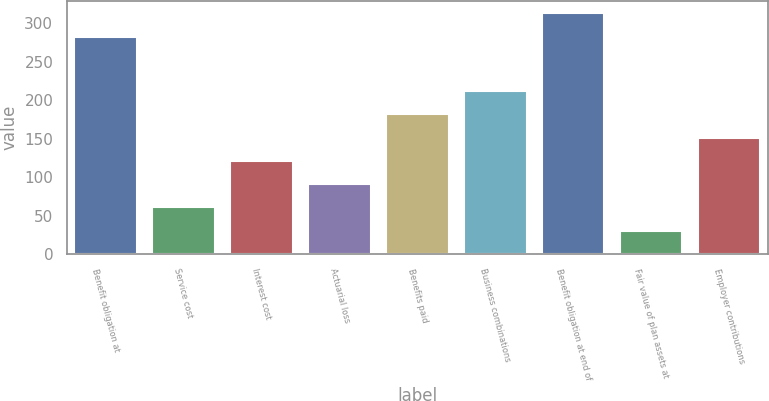Convert chart to OTSL. <chart><loc_0><loc_0><loc_500><loc_500><bar_chart><fcel>Benefit obligation at<fcel>Service cost<fcel>Interest cost<fcel>Actuarial loss<fcel>Benefits paid<fcel>Business combinations<fcel>Benefit obligation at end of<fcel>Fair value of plan assets at<fcel>Employer contributions<nl><fcel>282.7<fcel>60.64<fcel>121.18<fcel>90.91<fcel>181.72<fcel>211.99<fcel>312.97<fcel>30.37<fcel>151.45<nl></chart> 